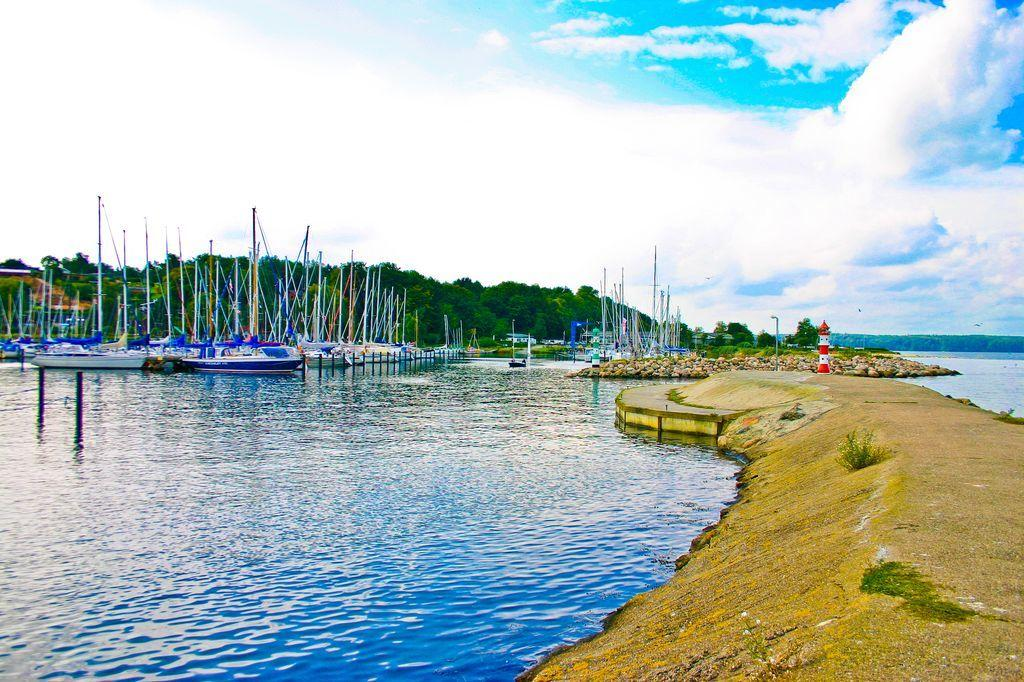What can be seen on the right side of the image? There is a path on the right side of the image. What is located on the left side of the image? There is a lake on the left side of the image. What is present on the lake? There are boats on the lake. What type of natural environment is visible in the background of the image? There are trees in the background of the image. What else can be seen in the background of the image? The sky is visible in the background of the image. Where is the volcano located in the image? There is no volcano present in the image. How does the tank move around in the image? There is no tank present in the image. 